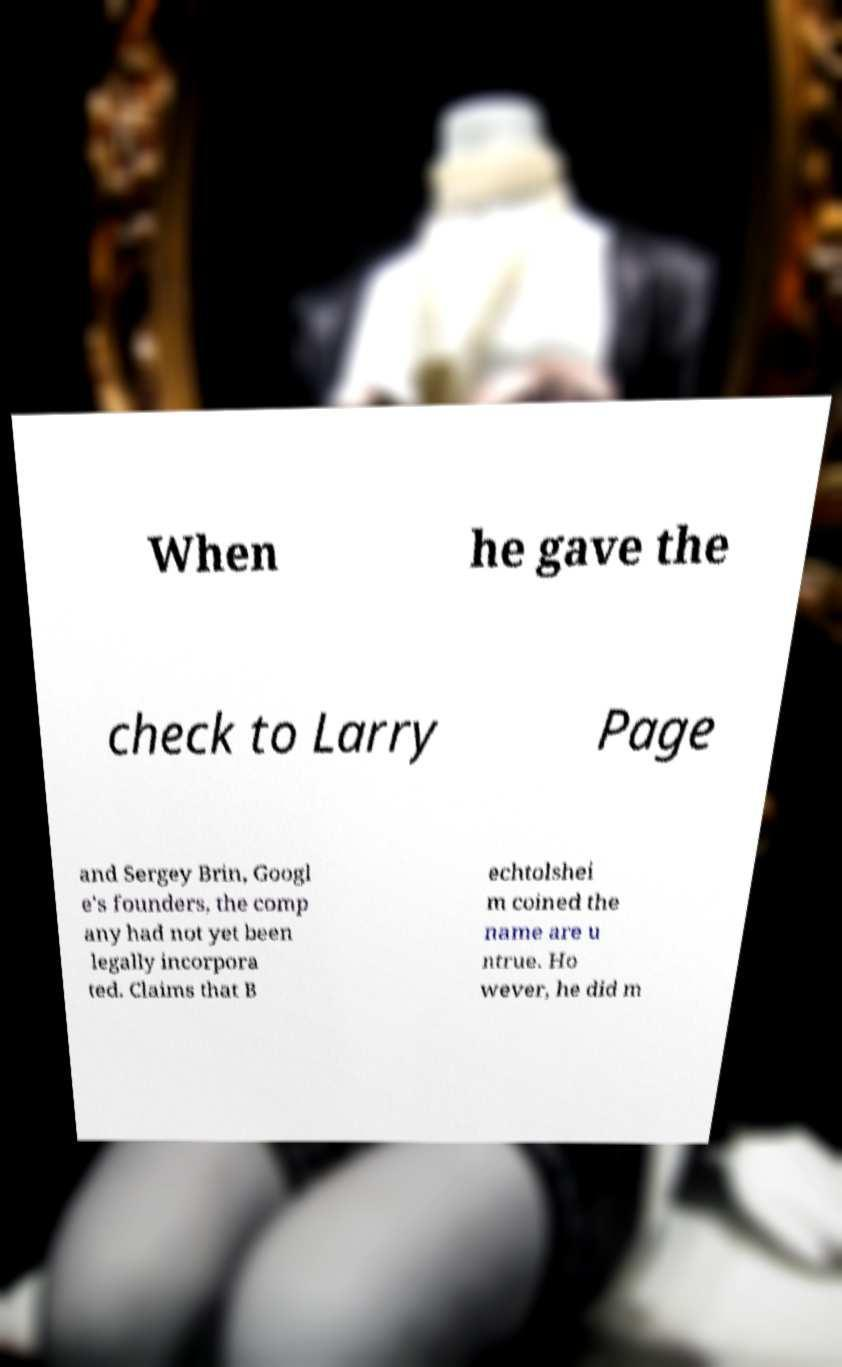Can you read and provide the text displayed in the image?This photo seems to have some interesting text. Can you extract and type it out for me? When he gave the check to Larry Page and Sergey Brin, Googl e's founders, the comp any had not yet been legally incorpora ted. Claims that B echtolshei m coined the name are u ntrue. Ho wever, he did m 